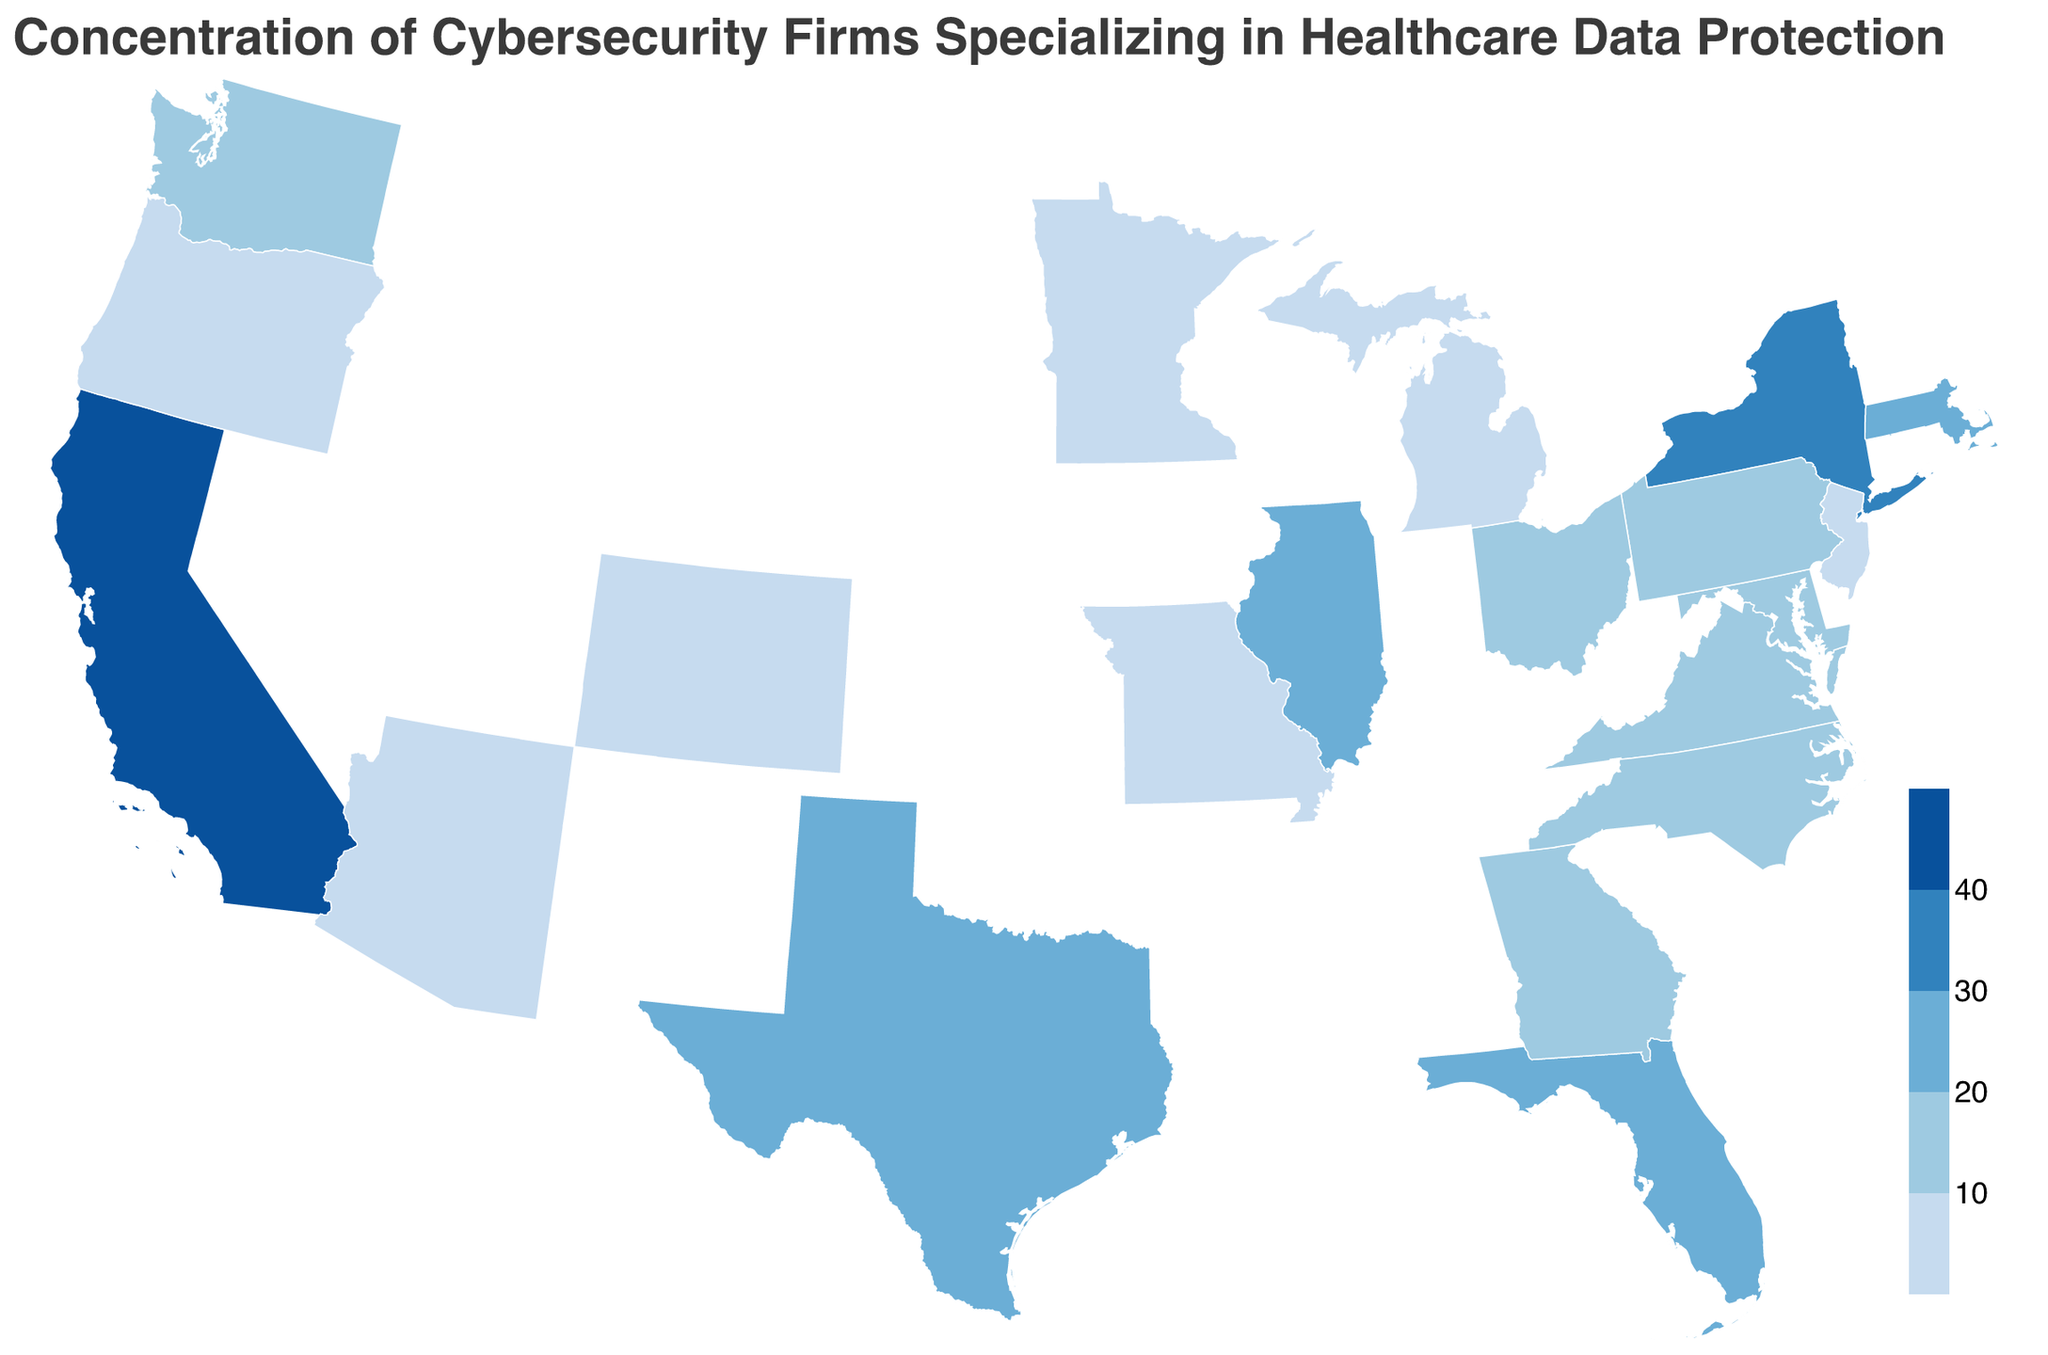Which state has the highest number of cybersecurity firms specializing in healthcare data protection? California is filled with the darkest color in the plot, which represents the highest number of cybersecurity firms at 42 firms.
Answer: California How many states have more than 20 cybersecurity firms? States with shades darker than the middle of the color spectrum have more than 20 firms. California, New York, Texas, and Massachusetts meet this criterion, totaling 4 states.
Answer: 4 What is the total number of cybersecurity firms in New York and Texas combined? New York has 35 firms, and Texas has 28 firms. Adding these together gives 35 + 28 = 63 firms.
Answer: 63 Which data point represents the median number of cybersecurity firms across all states listed? There are 20 states listed; the median is the average of the 10th and 11th values in the sorted list. PA has 15 firms and WA has 14 firms. Therefore, the median is (15 + 14) / 2 = 14.5.
Answer: 14.5 What is the maximum range of the number of firms among the states listed? The minimum number is 4 firms in Missouri, and the maximum is 42 firms in California. The range is 42 - 4 = 38 firms.
Answer: 38 Which state(s) have an equal number of cybersecurity firms? Arizona and Minnesota both have 6 firms, sharing the same value.
Answer: Arizona, Minnesota Which state has fewer cybersecurity firms: Virginia or Maryland? Virginia has 18 firms, whereas Maryland has 17 firms. Therefore, Maryland has fewer firms.
Answer: Maryland What is the total number of cybersecurity firms across the states that each have fewer than 10 firms? States with fewer than 10 firms are Colorado (9), New Jersey (8), Michigan (7), Arizona (6), Minnesota (6), Oregon (5), and Missouri (4). Summing these gives 9 + 8 + 7 + 6 + 6 + 5 + 4 = 45 firms.
Answer: 45 What kind of color gradient is used to represent the number of firms, and how is it divided? The color gradient uses threshold steps, increasing in darkness with >10, >20, >30, and >40 firms, corresponding to progressively darker shades of blue.
Answer: Threshold gradient How many states have data points that fall within the middle threshold range of the color gradient (20-30 firms)? The states that fall within this range are Texas, Massachusetts, and Florida, totaling 3 states.
Answer: 3 